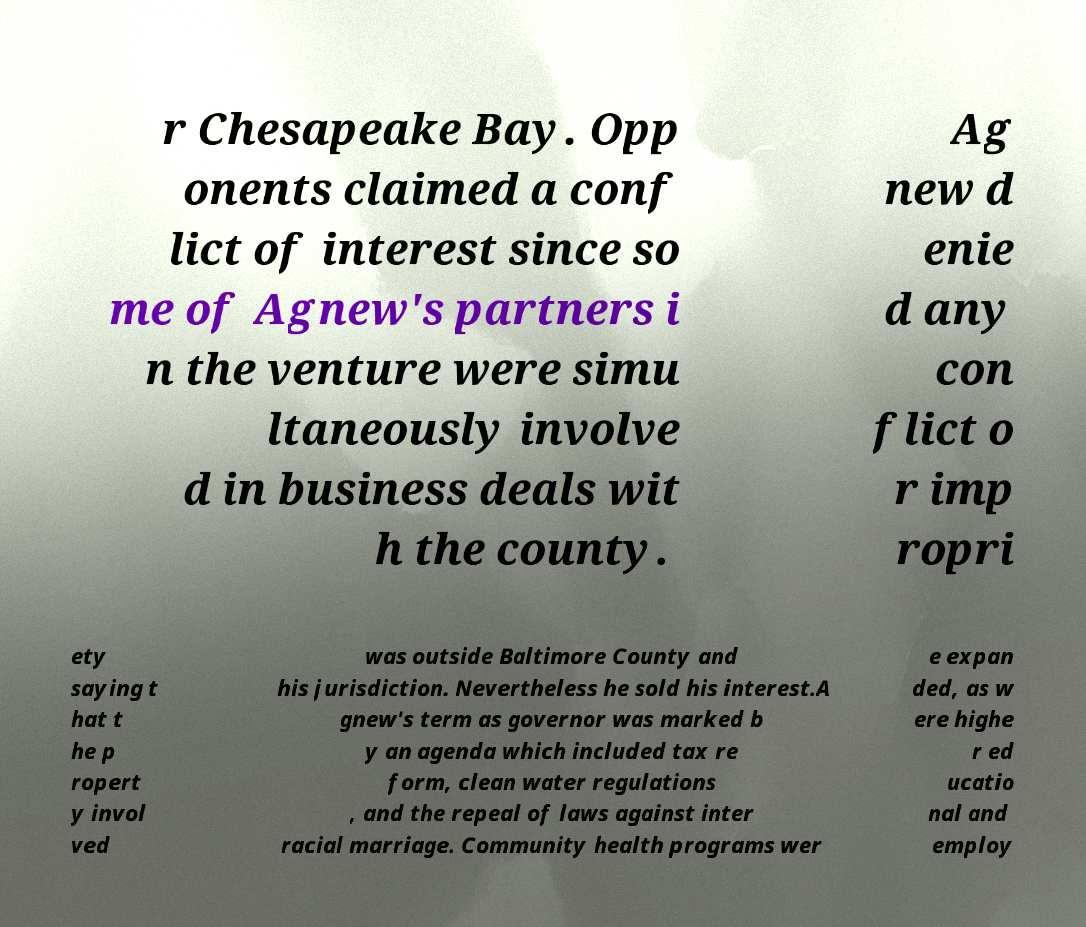Can you accurately transcribe the text from the provided image for me? r Chesapeake Bay. Opp onents claimed a conf lict of interest since so me of Agnew's partners i n the venture were simu ltaneously involve d in business deals wit h the county. Ag new d enie d any con flict o r imp ropri ety saying t hat t he p ropert y invol ved was outside Baltimore County and his jurisdiction. Nevertheless he sold his interest.A gnew's term as governor was marked b y an agenda which included tax re form, clean water regulations , and the repeal of laws against inter racial marriage. Community health programs wer e expan ded, as w ere highe r ed ucatio nal and employ 